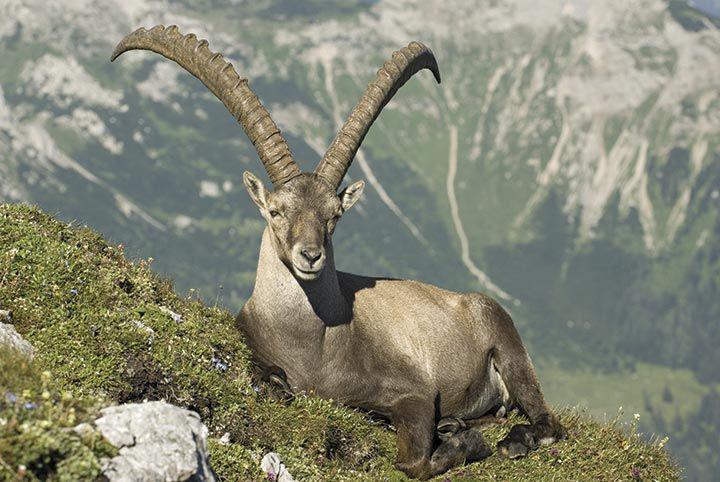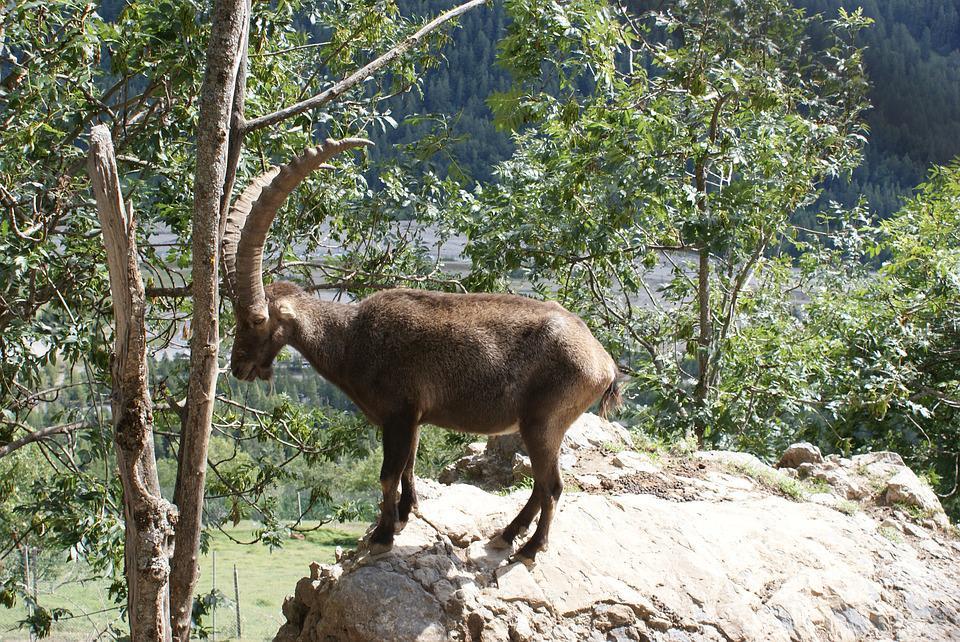The first image is the image on the left, the second image is the image on the right. Analyze the images presented: Is the assertion "The left and right image contains the same number of goats with one sitting." valid? Answer yes or no. Yes. The first image is the image on the left, the second image is the image on the right. For the images displayed, is the sentence "The left image contains one reclining long-horned animal with its front legs folded under and its head turned to face the camera." factually correct? Answer yes or no. Yes. 